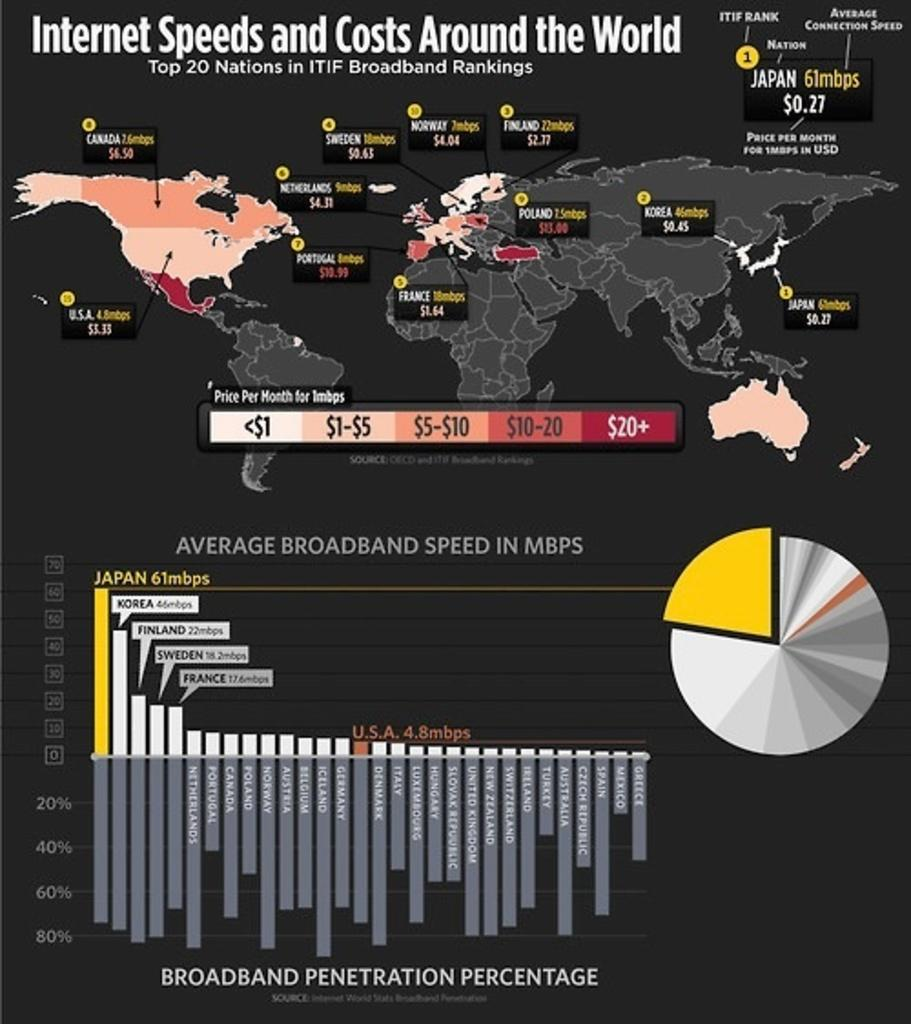Provide a one-sentence caption for the provided image. An infographic of internet speeds and costs throughout the world. 